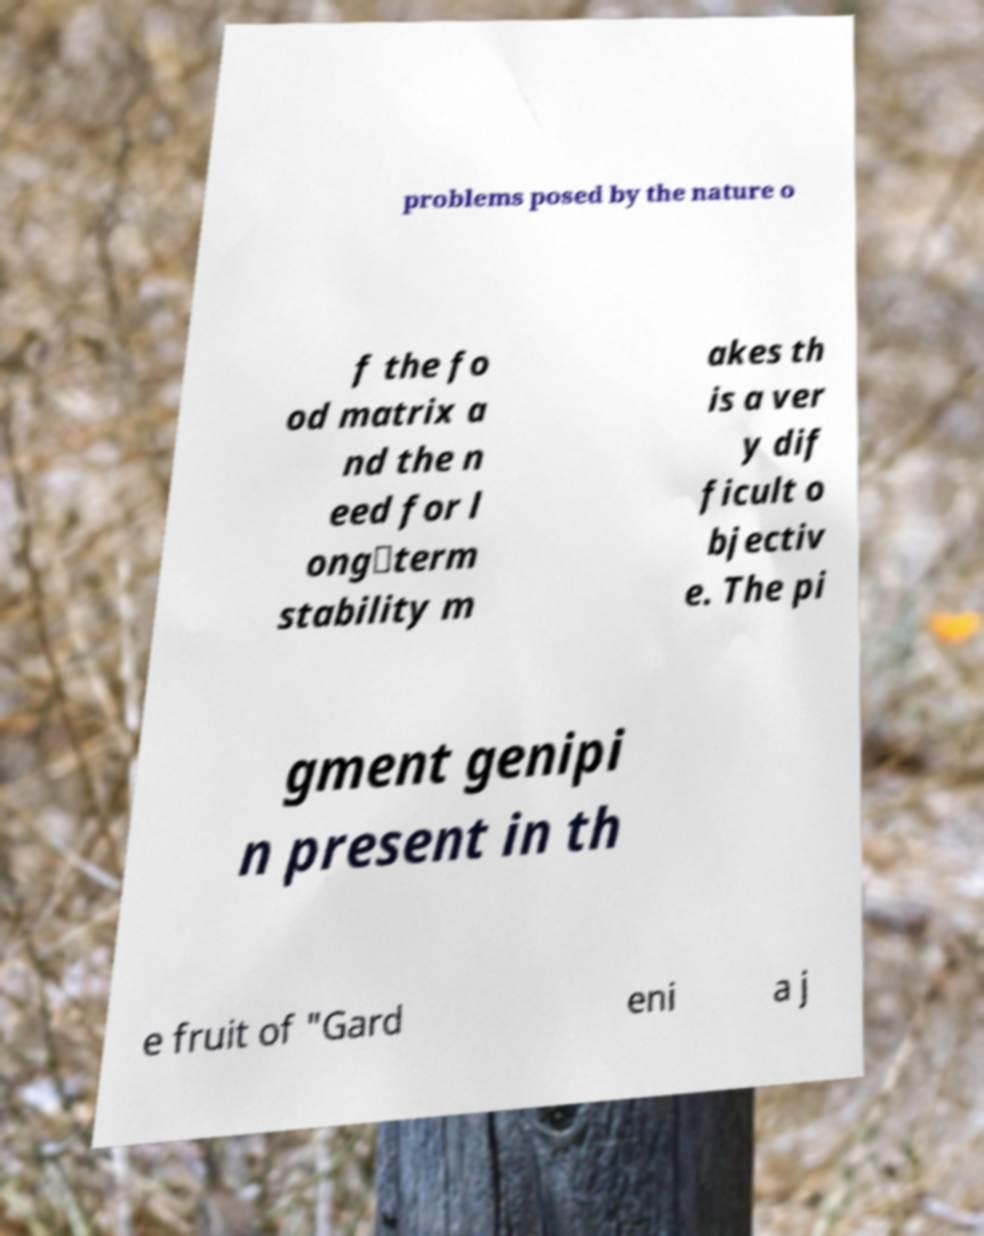Please identify and transcribe the text found in this image. problems posed by the nature o f the fo od matrix a nd the n eed for l ong‐term stability m akes th is a ver y dif ficult o bjectiv e. The pi gment genipi n present in th e fruit of "Gard eni a j 